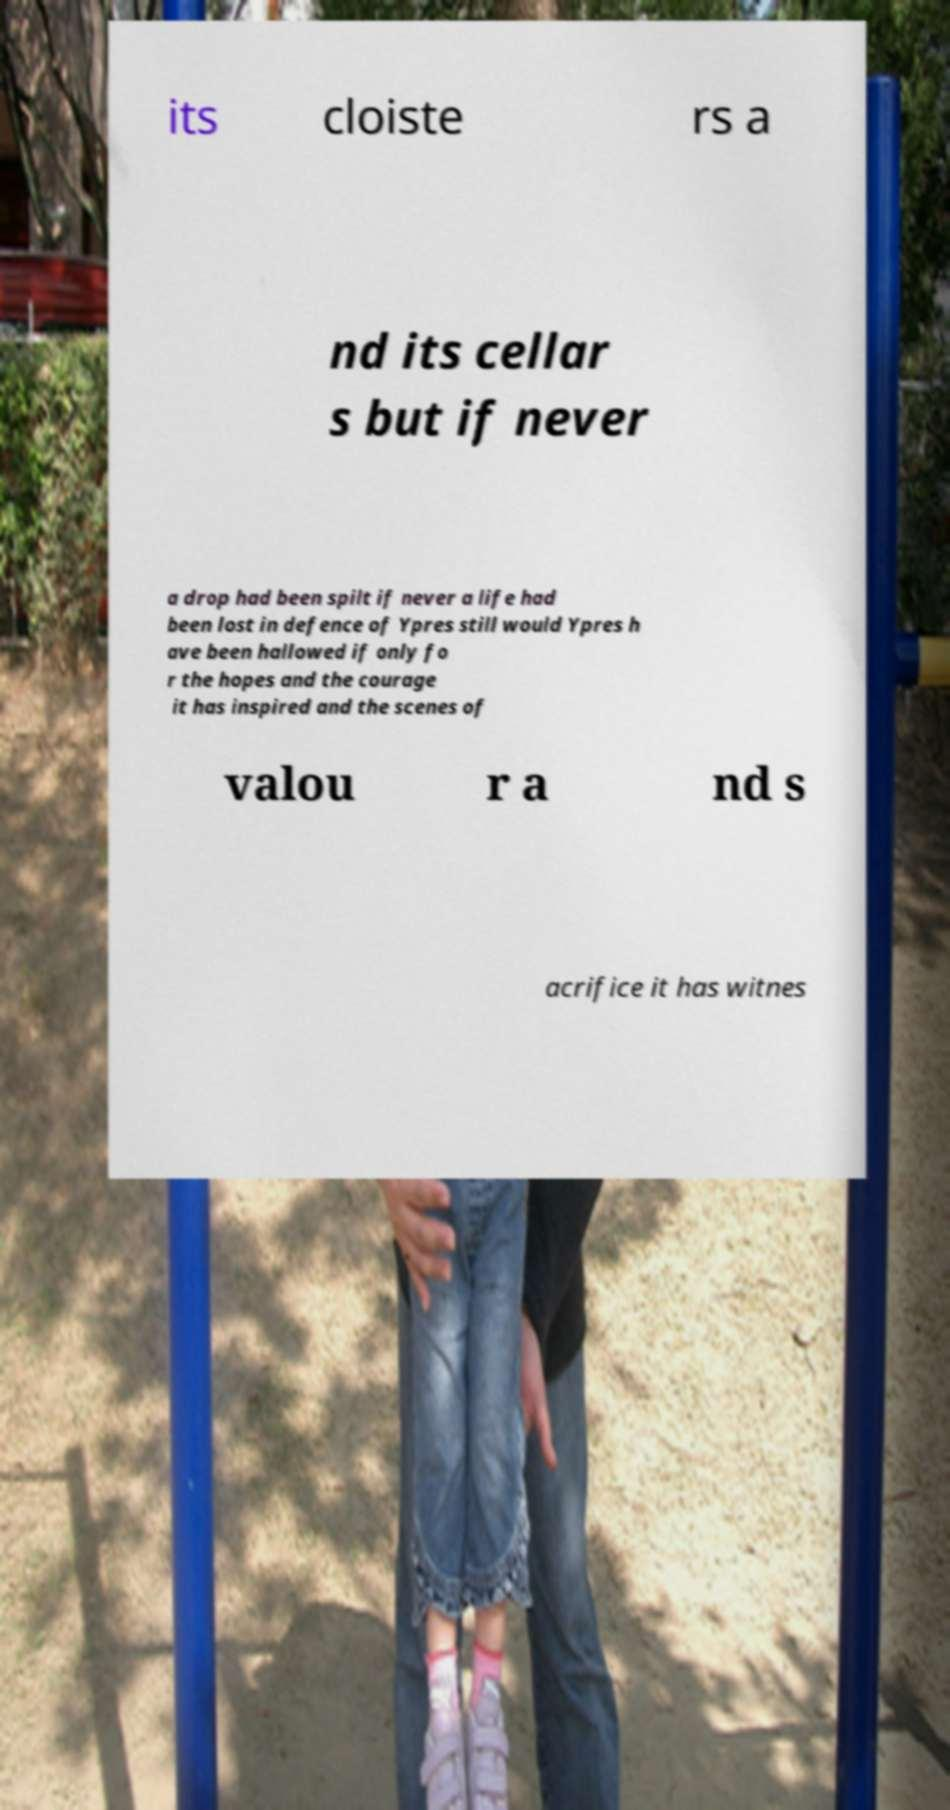Can you read and provide the text displayed in the image?This photo seems to have some interesting text. Can you extract and type it out for me? its cloiste rs a nd its cellar s but if never a drop had been spilt if never a life had been lost in defence of Ypres still would Ypres h ave been hallowed if only fo r the hopes and the courage it has inspired and the scenes of valou r a nd s acrifice it has witnes 